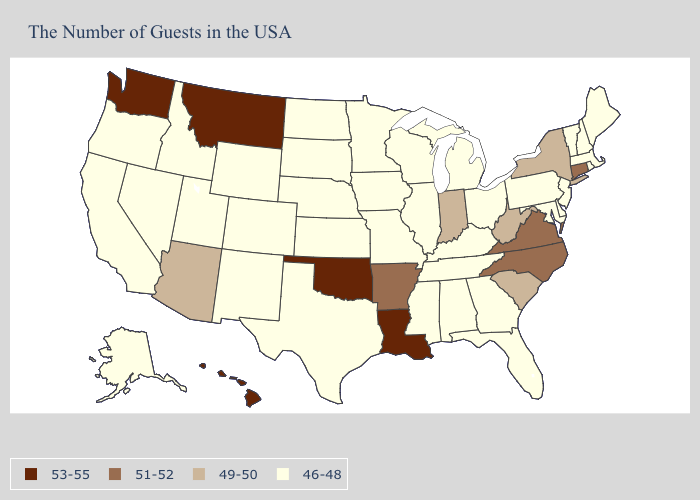Which states hav the highest value in the Northeast?
Concise answer only. Connecticut. Which states have the lowest value in the Northeast?
Be succinct. Maine, Massachusetts, Rhode Island, New Hampshire, Vermont, New Jersey, Pennsylvania. Name the states that have a value in the range 49-50?
Give a very brief answer. New York, South Carolina, West Virginia, Indiana, Arizona. What is the value of Wisconsin?
Quick response, please. 46-48. What is the lowest value in the USA?
Answer briefly. 46-48. What is the highest value in the USA?
Write a very short answer. 53-55. Among the states that border Rhode Island , which have the highest value?
Quick response, please. Connecticut. Among the states that border Minnesota , which have the lowest value?
Short answer required. Wisconsin, Iowa, South Dakota, North Dakota. What is the lowest value in the USA?
Be succinct. 46-48. Does the map have missing data?
Answer briefly. No. What is the value of Nevada?
Be succinct. 46-48. Name the states that have a value in the range 49-50?
Write a very short answer. New York, South Carolina, West Virginia, Indiana, Arizona. What is the value of Maine?
Give a very brief answer. 46-48. Which states have the lowest value in the USA?
Short answer required. Maine, Massachusetts, Rhode Island, New Hampshire, Vermont, New Jersey, Delaware, Maryland, Pennsylvania, Ohio, Florida, Georgia, Michigan, Kentucky, Alabama, Tennessee, Wisconsin, Illinois, Mississippi, Missouri, Minnesota, Iowa, Kansas, Nebraska, Texas, South Dakota, North Dakota, Wyoming, Colorado, New Mexico, Utah, Idaho, Nevada, California, Oregon, Alaska. Name the states that have a value in the range 46-48?
Answer briefly. Maine, Massachusetts, Rhode Island, New Hampshire, Vermont, New Jersey, Delaware, Maryland, Pennsylvania, Ohio, Florida, Georgia, Michigan, Kentucky, Alabama, Tennessee, Wisconsin, Illinois, Mississippi, Missouri, Minnesota, Iowa, Kansas, Nebraska, Texas, South Dakota, North Dakota, Wyoming, Colorado, New Mexico, Utah, Idaho, Nevada, California, Oregon, Alaska. 